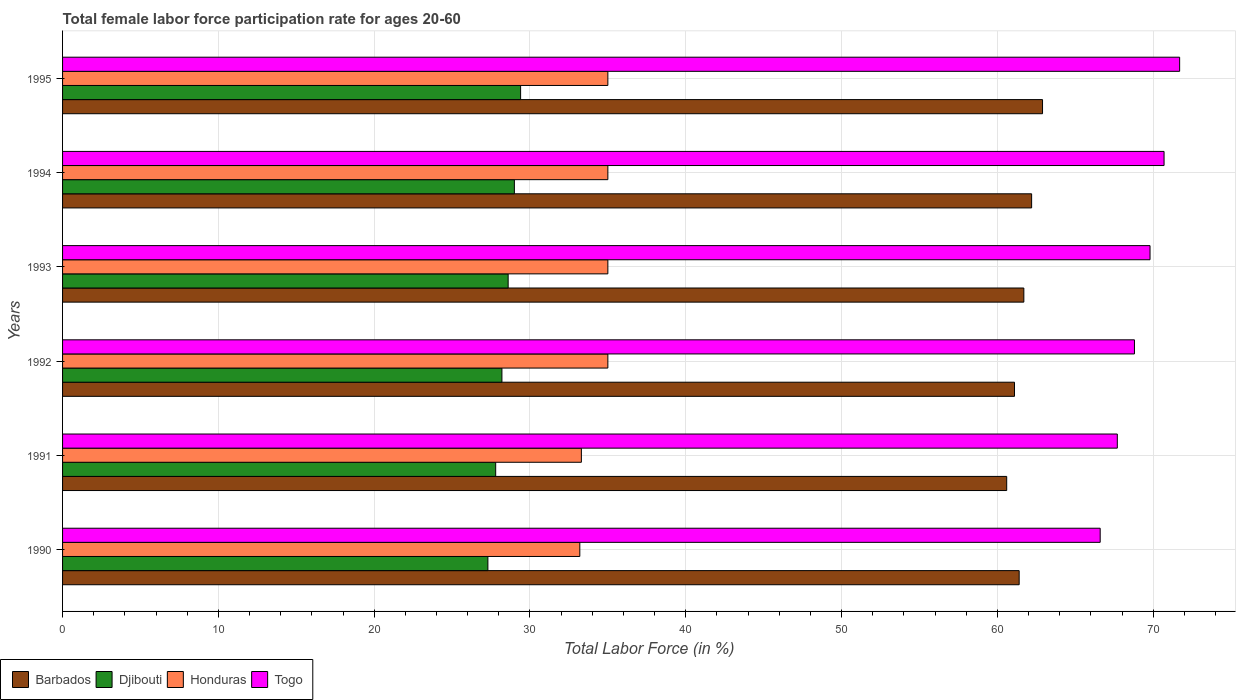How many groups of bars are there?
Your response must be concise. 6. Are the number of bars per tick equal to the number of legend labels?
Provide a succinct answer. Yes. Are the number of bars on each tick of the Y-axis equal?
Ensure brevity in your answer.  Yes. How many bars are there on the 3rd tick from the top?
Keep it short and to the point. 4. How many bars are there on the 4th tick from the bottom?
Your answer should be very brief. 4. What is the female labor force participation rate in Honduras in 1990?
Provide a short and direct response. 33.2. Across all years, what is the maximum female labor force participation rate in Barbados?
Provide a short and direct response. 62.9. Across all years, what is the minimum female labor force participation rate in Togo?
Your answer should be very brief. 66.6. In which year was the female labor force participation rate in Togo maximum?
Ensure brevity in your answer.  1995. What is the total female labor force participation rate in Barbados in the graph?
Offer a very short reply. 369.9. What is the difference between the female labor force participation rate in Honduras in 1990 and that in 1991?
Offer a very short reply. -0.1. What is the difference between the female labor force participation rate in Barbados in 1993 and the female labor force participation rate in Togo in 1995?
Your answer should be very brief. -10. What is the average female labor force participation rate in Honduras per year?
Your response must be concise. 34.42. In the year 1994, what is the difference between the female labor force participation rate in Honduras and female labor force participation rate in Djibouti?
Provide a short and direct response. 6. In how many years, is the female labor force participation rate in Barbados greater than 58 %?
Your answer should be compact. 6. What is the ratio of the female labor force participation rate in Djibouti in 1992 to that in 1995?
Give a very brief answer. 0.96. Is the female labor force participation rate in Djibouti in 1990 less than that in 1995?
Your response must be concise. Yes. What is the difference between the highest and the second highest female labor force participation rate in Barbados?
Your answer should be very brief. 0.7. What is the difference between the highest and the lowest female labor force participation rate in Honduras?
Offer a very short reply. 1.8. In how many years, is the female labor force participation rate in Togo greater than the average female labor force participation rate in Togo taken over all years?
Offer a terse response. 3. What does the 1st bar from the top in 1995 represents?
Your answer should be compact. Togo. What does the 2nd bar from the bottom in 1992 represents?
Offer a very short reply. Djibouti. Are the values on the major ticks of X-axis written in scientific E-notation?
Your response must be concise. No. Does the graph contain grids?
Your answer should be very brief. Yes. How many legend labels are there?
Your answer should be very brief. 4. What is the title of the graph?
Your answer should be very brief. Total female labor force participation rate for ages 20-60. Does "Zimbabwe" appear as one of the legend labels in the graph?
Offer a terse response. No. What is the label or title of the X-axis?
Give a very brief answer. Total Labor Force (in %). What is the label or title of the Y-axis?
Ensure brevity in your answer.  Years. What is the Total Labor Force (in %) of Barbados in 1990?
Offer a terse response. 61.4. What is the Total Labor Force (in %) of Djibouti in 1990?
Keep it short and to the point. 27.3. What is the Total Labor Force (in %) in Honduras in 1990?
Your response must be concise. 33.2. What is the Total Labor Force (in %) of Togo in 1990?
Your answer should be very brief. 66.6. What is the Total Labor Force (in %) of Barbados in 1991?
Keep it short and to the point. 60.6. What is the Total Labor Force (in %) of Djibouti in 1991?
Provide a short and direct response. 27.8. What is the Total Labor Force (in %) in Honduras in 1991?
Keep it short and to the point. 33.3. What is the Total Labor Force (in %) in Togo in 1991?
Keep it short and to the point. 67.7. What is the Total Labor Force (in %) of Barbados in 1992?
Your answer should be compact. 61.1. What is the Total Labor Force (in %) of Djibouti in 1992?
Offer a very short reply. 28.2. What is the Total Labor Force (in %) of Honduras in 1992?
Give a very brief answer. 35. What is the Total Labor Force (in %) of Togo in 1992?
Give a very brief answer. 68.8. What is the Total Labor Force (in %) in Barbados in 1993?
Provide a short and direct response. 61.7. What is the Total Labor Force (in %) in Djibouti in 1993?
Give a very brief answer. 28.6. What is the Total Labor Force (in %) of Togo in 1993?
Ensure brevity in your answer.  69.8. What is the Total Labor Force (in %) of Barbados in 1994?
Offer a very short reply. 62.2. What is the Total Labor Force (in %) of Togo in 1994?
Your response must be concise. 70.7. What is the Total Labor Force (in %) in Barbados in 1995?
Provide a short and direct response. 62.9. What is the Total Labor Force (in %) in Djibouti in 1995?
Provide a short and direct response. 29.4. What is the Total Labor Force (in %) of Togo in 1995?
Provide a short and direct response. 71.7. Across all years, what is the maximum Total Labor Force (in %) in Barbados?
Make the answer very short. 62.9. Across all years, what is the maximum Total Labor Force (in %) of Djibouti?
Your response must be concise. 29.4. Across all years, what is the maximum Total Labor Force (in %) of Honduras?
Your answer should be compact. 35. Across all years, what is the maximum Total Labor Force (in %) in Togo?
Provide a short and direct response. 71.7. Across all years, what is the minimum Total Labor Force (in %) of Barbados?
Offer a very short reply. 60.6. Across all years, what is the minimum Total Labor Force (in %) in Djibouti?
Make the answer very short. 27.3. Across all years, what is the minimum Total Labor Force (in %) of Honduras?
Keep it short and to the point. 33.2. Across all years, what is the minimum Total Labor Force (in %) in Togo?
Offer a very short reply. 66.6. What is the total Total Labor Force (in %) in Barbados in the graph?
Offer a terse response. 369.9. What is the total Total Labor Force (in %) in Djibouti in the graph?
Your answer should be compact. 170.3. What is the total Total Labor Force (in %) of Honduras in the graph?
Make the answer very short. 206.5. What is the total Total Labor Force (in %) of Togo in the graph?
Your response must be concise. 415.3. What is the difference between the Total Labor Force (in %) in Honduras in 1990 and that in 1992?
Provide a succinct answer. -1.8. What is the difference between the Total Labor Force (in %) in Honduras in 1990 and that in 1993?
Your answer should be compact. -1.8. What is the difference between the Total Labor Force (in %) of Togo in 1990 and that in 1993?
Give a very brief answer. -3.2. What is the difference between the Total Labor Force (in %) in Barbados in 1990 and that in 1994?
Offer a terse response. -0.8. What is the difference between the Total Labor Force (in %) of Djibouti in 1990 and that in 1994?
Make the answer very short. -1.7. What is the difference between the Total Labor Force (in %) of Togo in 1990 and that in 1994?
Ensure brevity in your answer.  -4.1. What is the difference between the Total Labor Force (in %) of Barbados in 1990 and that in 1995?
Offer a terse response. -1.5. What is the difference between the Total Labor Force (in %) of Djibouti in 1990 and that in 1995?
Provide a succinct answer. -2.1. What is the difference between the Total Labor Force (in %) in Togo in 1990 and that in 1995?
Ensure brevity in your answer.  -5.1. What is the difference between the Total Labor Force (in %) of Barbados in 1991 and that in 1992?
Your answer should be compact. -0.5. What is the difference between the Total Labor Force (in %) in Barbados in 1991 and that in 1993?
Your response must be concise. -1.1. What is the difference between the Total Labor Force (in %) of Djibouti in 1991 and that in 1993?
Give a very brief answer. -0.8. What is the difference between the Total Labor Force (in %) of Togo in 1991 and that in 1993?
Your response must be concise. -2.1. What is the difference between the Total Labor Force (in %) in Barbados in 1991 and that in 1994?
Make the answer very short. -1.6. What is the difference between the Total Labor Force (in %) in Honduras in 1991 and that in 1994?
Your answer should be compact. -1.7. What is the difference between the Total Labor Force (in %) in Togo in 1991 and that in 1994?
Provide a succinct answer. -3. What is the difference between the Total Labor Force (in %) of Barbados in 1991 and that in 1995?
Give a very brief answer. -2.3. What is the difference between the Total Labor Force (in %) in Djibouti in 1991 and that in 1995?
Provide a short and direct response. -1.6. What is the difference between the Total Labor Force (in %) in Togo in 1991 and that in 1995?
Provide a succinct answer. -4. What is the difference between the Total Labor Force (in %) in Djibouti in 1992 and that in 1993?
Offer a terse response. -0.4. What is the difference between the Total Labor Force (in %) of Djibouti in 1992 and that in 1994?
Ensure brevity in your answer.  -0.8. What is the difference between the Total Labor Force (in %) in Honduras in 1992 and that in 1994?
Offer a very short reply. 0. What is the difference between the Total Labor Force (in %) of Djibouti in 1992 and that in 1995?
Offer a terse response. -1.2. What is the difference between the Total Labor Force (in %) of Djibouti in 1993 and that in 1994?
Provide a succinct answer. -0.4. What is the difference between the Total Labor Force (in %) in Togo in 1993 and that in 1994?
Offer a terse response. -0.9. What is the difference between the Total Labor Force (in %) in Togo in 1993 and that in 1995?
Make the answer very short. -1.9. What is the difference between the Total Labor Force (in %) in Barbados in 1994 and that in 1995?
Your answer should be very brief. -0.7. What is the difference between the Total Labor Force (in %) of Djibouti in 1994 and that in 1995?
Your answer should be very brief. -0.4. What is the difference between the Total Labor Force (in %) of Honduras in 1994 and that in 1995?
Ensure brevity in your answer.  0. What is the difference between the Total Labor Force (in %) in Barbados in 1990 and the Total Labor Force (in %) in Djibouti in 1991?
Provide a succinct answer. 33.6. What is the difference between the Total Labor Force (in %) of Barbados in 1990 and the Total Labor Force (in %) of Honduras in 1991?
Offer a terse response. 28.1. What is the difference between the Total Labor Force (in %) in Barbados in 1990 and the Total Labor Force (in %) in Togo in 1991?
Your response must be concise. -6.3. What is the difference between the Total Labor Force (in %) of Djibouti in 1990 and the Total Labor Force (in %) of Honduras in 1991?
Provide a short and direct response. -6. What is the difference between the Total Labor Force (in %) in Djibouti in 1990 and the Total Labor Force (in %) in Togo in 1991?
Your answer should be compact. -40.4. What is the difference between the Total Labor Force (in %) of Honduras in 1990 and the Total Labor Force (in %) of Togo in 1991?
Offer a terse response. -34.5. What is the difference between the Total Labor Force (in %) in Barbados in 1990 and the Total Labor Force (in %) in Djibouti in 1992?
Provide a succinct answer. 33.2. What is the difference between the Total Labor Force (in %) in Barbados in 1990 and the Total Labor Force (in %) in Honduras in 1992?
Your response must be concise. 26.4. What is the difference between the Total Labor Force (in %) of Djibouti in 1990 and the Total Labor Force (in %) of Honduras in 1992?
Your answer should be compact. -7.7. What is the difference between the Total Labor Force (in %) in Djibouti in 1990 and the Total Labor Force (in %) in Togo in 1992?
Offer a very short reply. -41.5. What is the difference between the Total Labor Force (in %) in Honduras in 1990 and the Total Labor Force (in %) in Togo in 1992?
Your answer should be compact. -35.6. What is the difference between the Total Labor Force (in %) in Barbados in 1990 and the Total Labor Force (in %) in Djibouti in 1993?
Provide a short and direct response. 32.8. What is the difference between the Total Labor Force (in %) of Barbados in 1990 and the Total Labor Force (in %) of Honduras in 1993?
Make the answer very short. 26.4. What is the difference between the Total Labor Force (in %) of Djibouti in 1990 and the Total Labor Force (in %) of Honduras in 1993?
Ensure brevity in your answer.  -7.7. What is the difference between the Total Labor Force (in %) in Djibouti in 1990 and the Total Labor Force (in %) in Togo in 1993?
Offer a very short reply. -42.5. What is the difference between the Total Labor Force (in %) in Honduras in 1990 and the Total Labor Force (in %) in Togo in 1993?
Your answer should be compact. -36.6. What is the difference between the Total Labor Force (in %) in Barbados in 1990 and the Total Labor Force (in %) in Djibouti in 1994?
Offer a terse response. 32.4. What is the difference between the Total Labor Force (in %) of Barbados in 1990 and the Total Labor Force (in %) of Honduras in 1994?
Offer a terse response. 26.4. What is the difference between the Total Labor Force (in %) of Barbados in 1990 and the Total Labor Force (in %) of Togo in 1994?
Provide a succinct answer. -9.3. What is the difference between the Total Labor Force (in %) of Djibouti in 1990 and the Total Labor Force (in %) of Honduras in 1994?
Provide a succinct answer. -7.7. What is the difference between the Total Labor Force (in %) in Djibouti in 1990 and the Total Labor Force (in %) in Togo in 1994?
Make the answer very short. -43.4. What is the difference between the Total Labor Force (in %) of Honduras in 1990 and the Total Labor Force (in %) of Togo in 1994?
Your response must be concise. -37.5. What is the difference between the Total Labor Force (in %) of Barbados in 1990 and the Total Labor Force (in %) of Honduras in 1995?
Your answer should be compact. 26.4. What is the difference between the Total Labor Force (in %) in Djibouti in 1990 and the Total Labor Force (in %) in Togo in 1995?
Your answer should be compact. -44.4. What is the difference between the Total Labor Force (in %) of Honduras in 1990 and the Total Labor Force (in %) of Togo in 1995?
Your response must be concise. -38.5. What is the difference between the Total Labor Force (in %) in Barbados in 1991 and the Total Labor Force (in %) in Djibouti in 1992?
Make the answer very short. 32.4. What is the difference between the Total Labor Force (in %) of Barbados in 1991 and the Total Labor Force (in %) of Honduras in 1992?
Your response must be concise. 25.6. What is the difference between the Total Labor Force (in %) in Barbados in 1991 and the Total Labor Force (in %) in Togo in 1992?
Keep it short and to the point. -8.2. What is the difference between the Total Labor Force (in %) in Djibouti in 1991 and the Total Labor Force (in %) in Honduras in 1992?
Offer a very short reply. -7.2. What is the difference between the Total Labor Force (in %) in Djibouti in 1991 and the Total Labor Force (in %) in Togo in 1992?
Make the answer very short. -41. What is the difference between the Total Labor Force (in %) of Honduras in 1991 and the Total Labor Force (in %) of Togo in 1992?
Give a very brief answer. -35.5. What is the difference between the Total Labor Force (in %) in Barbados in 1991 and the Total Labor Force (in %) in Honduras in 1993?
Your answer should be compact. 25.6. What is the difference between the Total Labor Force (in %) of Djibouti in 1991 and the Total Labor Force (in %) of Togo in 1993?
Give a very brief answer. -42. What is the difference between the Total Labor Force (in %) of Honduras in 1991 and the Total Labor Force (in %) of Togo in 1993?
Offer a terse response. -36.5. What is the difference between the Total Labor Force (in %) in Barbados in 1991 and the Total Labor Force (in %) in Djibouti in 1994?
Offer a very short reply. 31.6. What is the difference between the Total Labor Force (in %) of Barbados in 1991 and the Total Labor Force (in %) of Honduras in 1994?
Offer a very short reply. 25.6. What is the difference between the Total Labor Force (in %) in Barbados in 1991 and the Total Labor Force (in %) in Togo in 1994?
Your response must be concise. -10.1. What is the difference between the Total Labor Force (in %) of Djibouti in 1991 and the Total Labor Force (in %) of Honduras in 1994?
Your answer should be very brief. -7.2. What is the difference between the Total Labor Force (in %) in Djibouti in 1991 and the Total Labor Force (in %) in Togo in 1994?
Your response must be concise. -42.9. What is the difference between the Total Labor Force (in %) in Honduras in 1991 and the Total Labor Force (in %) in Togo in 1994?
Ensure brevity in your answer.  -37.4. What is the difference between the Total Labor Force (in %) in Barbados in 1991 and the Total Labor Force (in %) in Djibouti in 1995?
Keep it short and to the point. 31.2. What is the difference between the Total Labor Force (in %) of Barbados in 1991 and the Total Labor Force (in %) of Honduras in 1995?
Offer a very short reply. 25.6. What is the difference between the Total Labor Force (in %) of Djibouti in 1991 and the Total Labor Force (in %) of Togo in 1995?
Your answer should be very brief. -43.9. What is the difference between the Total Labor Force (in %) in Honduras in 1991 and the Total Labor Force (in %) in Togo in 1995?
Give a very brief answer. -38.4. What is the difference between the Total Labor Force (in %) in Barbados in 1992 and the Total Labor Force (in %) in Djibouti in 1993?
Offer a terse response. 32.5. What is the difference between the Total Labor Force (in %) of Barbados in 1992 and the Total Labor Force (in %) of Honduras in 1993?
Your response must be concise. 26.1. What is the difference between the Total Labor Force (in %) of Djibouti in 1992 and the Total Labor Force (in %) of Togo in 1993?
Provide a succinct answer. -41.6. What is the difference between the Total Labor Force (in %) in Honduras in 1992 and the Total Labor Force (in %) in Togo in 1993?
Your response must be concise. -34.8. What is the difference between the Total Labor Force (in %) of Barbados in 1992 and the Total Labor Force (in %) of Djibouti in 1994?
Offer a terse response. 32.1. What is the difference between the Total Labor Force (in %) in Barbados in 1992 and the Total Labor Force (in %) in Honduras in 1994?
Offer a very short reply. 26.1. What is the difference between the Total Labor Force (in %) of Barbados in 1992 and the Total Labor Force (in %) of Togo in 1994?
Your answer should be compact. -9.6. What is the difference between the Total Labor Force (in %) of Djibouti in 1992 and the Total Labor Force (in %) of Togo in 1994?
Provide a short and direct response. -42.5. What is the difference between the Total Labor Force (in %) of Honduras in 1992 and the Total Labor Force (in %) of Togo in 1994?
Your answer should be very brief. -35.7. What is the difference between the Total Labor Force (in %) in Barbados in 1992 and the Total Labor Force (in %) in Djibouti in 1995?
Your answer should be very brief. 31.7. What is the difference between the Total Labor Force (in %) of Barbados in 1992 and the Total Labor Force (in %) of Honduras in 1995?
Ensure brevity in your answer.  26.1. What is the difference between the Total Labor Force (in %) in Djibouti in 1992 and the Total Labor Force (in %) in Honduras in 1995?
Provide a short and direct response. -6.8. What is the difference between the Total Labor Force (in %) of Djibouti in 1992 and the Total Labor Force (in %) of Togo in 1995?
Make the answer very short. -43.5. What is the difference between the Total Labor Force (in %) of Honduras in 1992 and the Total Labor Force (in %) of Togo in 1995?
Provide a succinct answer. -36.7. What is the difference between the Total Labor Force (in %) of Barbados in 1993 and the Total Labor Force (in %) of Djibouti in 1994?
Provide a succinct answer. 32.7. What is the difference between the Total Labor Force (in %) of Barbados in 1993 and the Total Labor Force (in %) of Honduras in 1994?
Offer a very short reply. 26.7. What is the difference between the Total Labor Force (in %) in Djibouti in 1993 and the Total Labor Force (in %) in Togo in 1994?
Offer a very short reply. -42.1. What is the difference between the Total Labor Force (in %) in Honduras in 1993 and the Total Labor Force (in %) in Togo in 1994?
Your answer should be very brief. -35.7. What is the difference between the Total Labor Force (in %) of Barbados in 1993 and the Total Labor Force (in %) of Djibouti in 1995?
Ensure brevity in your answer.  32.3. What is the difference between the Total Labor Force (in %) of Barbados in 1993 and the Total Labor Force (in %) of Honduras in 1995?
Offer a very short reply. 26.7. What is the difference between the Total Labor Force (in %) in Barbados in 1993 and the Total Labor Force (in %) in Togo in 1995?
Provide a short and direct response. -10. What is the difference between the Total Labor Force (in %) of Djibouti in 1993 and the Total Labor Force (in %) of Togo in 1995?
Give a very brief answer. -43.1. What is the difference between the Total Labor Force (in %) in Honduras in 1993 and the Total Labor Force (in %) in Togo in 1995?
Offer a very short reply. -36.7. What is the difference between the Total Labor Force (in %) of Barbados in 1994 and the Total Labor Force (in %) of Djibouti in 1995?
Provide a short and direct response. 32.8. What is the difference between the Total Labor Force (in %) in Barbados in 1994 and the Total Labor Force (in %) in Honduras in 1995?
Offer a terse response. 27.2. What is the difference between the Total Labor Force (in %) in Barbados in 1994 and the Total Labor Force (in %) in Togo in 1995?
Keep it short and to the point. -9.5. What is the difference between the Total Labor Force (in %) in Djibouti in 1994 and the Total Labor Force (in %) in Togo in 1995?
Keep it short and to the point. -42.7. What is the difference between the Total Labor Force (in %) in Honduras in 1994 and the Total Labor Force (in %) in Togo in 1995?
Ensure brevity in your answer.  -36.7. What is the average Total Labor Force (in %) in Barbados per year?
Your response must be concise. 61.65. What is the average Total Labor Force (in %) in Djibouti per year?
Give a very brief answer. 28.38. What is the average Total Labor Force (in %) in Honduras per year?
Offer a terse response. 34.42. What is the average Total Labor Force (in %) in Togo per year?
Offer a terse response. 69.22. In the year 1990, what is the difference between the Total Labor Force (in %) of Barbados and Total Labor Force (in %) of Djibouti?
Provide a short and direct response. 34.1. In the year 1990, what is the difference between the Total Labor Force (in %) of Barbados and Total Labor Force (in %) of Honduras?
Your answer should be very brief. 28.2. In the year 1990, what is the difference between the Total Labor Force (in %) in Djibouti and Total Labor Force (in %) in Honduras?
Give a very brief answer. -5.9. In the year 1990, what is the difference between the Total Labor Force (in %) of Djibouti and Total Labor Force (in %) of Togo?
Your answer should be compact. -39.3. In the year 1990, what is the difference between the Total Labor Force (in %) of Honduras and Total Labor Force (in %) of Togo?
Your response must be concise. -33.4. In the year 1991, what is the difference between the Total Labor Force (in %) in Barbados and Total Labor Force (in %) in Djibouti?
Offer a very short reply. 32.8. In the year 1991, what is the difference between the Total Labor Force (in %) in Barbados and Total Labor Force (in %) in Honduras?
Offer a terse response. 27.3. In the year 1991, what is the difference between the Total Labor Force (in %) in Djibouti and Total Labor Force (in %) in Honduras?
Provide a short and direct response. -5.5. In the year 1991, what is the difference between the Total Labor Force (in %) in Djibouti and Total Labor Force (in %) in Togo?
Provide a succinct answer. -39.9. In the year 1991, what is the difference between the Total Labor Force (in %) in Honduras and Total Labor Force (in %) in Togo?
Provide a succinct answer. -34.4. In the year 1992, what is the difference between the Total Labor Force (in %) of Barbados and Total Labor Force (in %) of Djibouti?
Your answer should be compact. 32.9. In the year 1992, what is the difference between the Total Labor Force (in %) in Barbados and Total Labor Force (in %) in Honduras?
Keep it short and to the point. 26.1. In the year 1992, what is the difference between the Total Labor Force (in %) in Barbados and Total Labor Force (in %) in Togo?
Provide a succinct answer. -7.7. In the year 1992, what is the difference between the Total Labor Force (in %) in Djibouti and Total Labor Force (in %) in Honduras?
Give a very brief answer. -6.8. In the year 1992, what is the difference between the Total Labor Force (in %) in Djibouti and Total Labor Force (in %) in Togo?
Your answer should be very brief. -40.6. In the year 1992, what is the difference between the Total Labor Force (in %) of Honduras and Total Labor Force (in %) of Togo?
Provide a short and direct response. -33.8. In the year 1993, what is the difference between the Total Labor Force (in %) in Barbados and Total Labor Force (in %) in Djibouti?
Provide a short and direct response. 33.1. In the year 1993, what is the difference between the Total Labor Force (in %) in Barbados and Total Labor Force (in %) in Honduras?
Offer a very short reply. 26.7. In the year 1993, what is the difference between the Total Labor Force (in %) of Djibouti and Total Labor Force (in %) of Honduras?
Provide a short and direct response. -6.4. In the year 1993, what is the difference between the Total Labor Force (in %) of Djibouti and Total Labor Force (in %) of Togo?
Make the answer very short. -41.2. In the year 1993, what is the difference between the Total Labor Force (in %) in Honduras and Total Labor Force (in %) in Togo?
Your answer should be very brief. -34.8. In the year 1994, what is the difference between the Total Labor Force (in %) of Barbados and Total Labor Force (in %) of Djibouti?
Make the answer very short. 33.2. In the year 1994, what is the difference between the Total Labor Force (in %) of Barbados and Total Labor Force (in %) of Honduras?
Offer a terse response. 27.2. In the year 1994, what is the difference between the Total Labor Force (in %) in Barbados and Total Labor Force (in %) in Togo?
Your response must be concise. -8.5. In the year 1994, what is the difference between the Total Labor Force (in %) in Djibouti and Total Labor Force (in %) in Togo?
Your answer should be compact. -41.7. In the year 1994, what is the difference between the Total Labor Force (in %) of Honduras and Total Labor Force (in %) of Togo?
Offer a terse response. -35.7. In the year 1995, what is the difference between the Total Labor Force (in %) of Barbados and Total Labor Force (in %) of Djibouti?
Keep it short and to the point. 33.5. In the year 1995, what is the difference between the Total Labor Force (in %) of Barbados and Total Labor Force (in %) of Honduras?
Provide a short and direct response. 27.9. In the year 1995, what is the difference between the Total Labor Force (in %) in Djibouti and Total Labor Force (in %) in Togo?
Keep it short and to the point. -42.3. In the year 1995, what is the difference between the Total Labor Force (in %) of Honduras and Total Labor Force (in %) of Togo?
Provide a succinct answer. -36.7. What is the ratio of the Total Labor Force (in %) in Barbados in 1990 to that in 1991?
Provide a short and direct response. 1.01. What is the ratio of the Total Labor Force (in %) in Honduras in 1990 to that in 1991?
Provide a succinct answer. 1. What is the ratio of the Total Labor Force (in %) of Togo in 1990 to that in 1991?
Keep it short and to the point. 0.98. What is the ratio of the Total Labor Force (in %) in Barbados in 1990 to that in 1992?
Your response must be concise. 1. What is the ratio of the Total Labor Force (in %) in Djibouti in 1990 to that in 1992?
Offer a terse response. 0.97. What is the ratio of the Total Labor Force (in %) of Honduras in 1990 to that in 1992?
Give a very brief answer. 0.95. What is the ratio of the Total Labor Force (in %) of Togo in 1990 to that in 1992?
Offer a very short reply. 0.97. What is the ratio of the Total Labor Force (in %) in Barbados in 1990 to that in 1993?
Offer a terse response. 1. What is the ratio of the Total Labor Force (in %) in Djibouti in 1990 to that in 1993?
Your answer should be very brief. 0.95. What is the ratio of the Total Labor Force (in %) in Honduras in 1990 to that in 1993?
Your answer should be compact. 0.95. What is the ratio of the Total Labor Force (in %) of Togo in 1990 to that in 1993?
Give a very brief answer. 0.95. What is the ratio of the Total Labor Force (in %) of Barbados in 1990 to that in 1994?
Keep it short and to the point. 0.99. What is the ratio of the Total Labor Force (in %) in Djibouti in 1990 to that in 1994?
Offer a very short reply. 0.94. What is the ratio of the Total Labor Force (in %) of Honduras in 1990 to that in 1994?
Provide a succinct answer. 0.95. What is the ratio of the Total Labor Force (in %) of Togo in 1990 to that in 1994?
Give a very brief answer. 0.94. What is the ratio of the Total Labor Force (in %) in Barbados in 1990 to that in 1995?
Keep it short and to the point. 0.98. What is the ratio of the Total Labor Force (in %) in Honduras in 1990 to that in 1995?
Provide a short and direct response. 0.95. What is the ratio of the Total Labor Force (in %) in Togo in 1990 to that in 1995?
Provide a succinct answer. 0.93. What is the ratio of the Total Labor Force (in %) in Djibouti in 1991 to that in 1992?
Give a very brief answer. 0.99. What is the ratio of the Total Labor Force (in %) in Honduras in 1991 to that in 1992?
Ensure brevity in your answer.  0.95. What is the ratio of the Total Labor Force (in %) of Togo in 1991 to that in 1992?
Provide a succinct answer. 0.98. What is the ratio of the Total Labor Force (in %) in Barbados in 1991 to that in 1993?
Your answer should be compact. 0.98. What is the ratio of the Total Labor Force (in %) of Djibouti in 1991 to that in 1993?
Provide a succinct answer. 0.97. What is the ratio of the Total Labor Force (in %) in Honduras in 1991 to that in 1993?
Offer a very short reply. 0.95. What is the ratio of the Total Labor Force (in %) of Togo in 1991 to that in 1993?
Offer a terse response. 0.97. What is the ratio of the Total Labor Force (in %) in Barbados in 1991 to that in 1994?
Ensure brevity in your answer.  0.97. What is the ratio of the Total Labor Force (in %) of Djibouti in 1991 to that in 1994?
Ensure brevity in your answer.  0.96. What is the ratio of the Total Labor Force (in %) in Honduras in 1991 to that in 1994?
Your response must be concise. 0.95. What is the ratio of the Total Labor Force (in %) of Togo in 1991 to that in 1994?
Provide a short and direct response. 0.96. What is the ratio of the Total Labor Force (in %) in Barbados in 1991 to that in 1995?
Your answer should be very brief. 0.96. What is the ratio of the Total Labor Force (in %) in Djibouti in 1991 to that in 1995?
Offer a terse response. 0.95. What is the ratio of the Total Labor Force (in %) in Honduras in 1991 to that in 1995?
Offer a terse response. 0.95. What is the ratio of the Total Labor Force (in %) in Togo in 1991 to that in 1995?
Give a very brief answer. 0.94. What is the ratio of the Total Labor Force (in %) of Barbados in 1992 to that in 1993?
Provide a succinct answer. 0.99. What is the ratio of the Total Labor Force (in %) in Honduras in 1992 to that in 1993?
Offer a very short reply. 1. What is the ratio of the Total Labor Force (in %) of Togo in 1992 to that in 1993?
Provide a short and direct response. 0.99. What is the ratio of the Total Labor Force (in %) in Barbados in 1992 to that in 1994?
Your response must be concise. 0.98. What is the ratio of the Total Labor Force (in %) in Djibouti in 1992 to that in 1994?
Offer a very short reply. 0.97. What is the ratio of the Total Labor Force (in %) in Honduras in 1992 to that in 1994?
Your answer should be compact. 1. What is the ratio of the Total Labor Force (in %) in Togo in 1992 to that in 1994?
Offer a terse response. 0.97. What is the ratio of the Total Labor Force (in %) of Barbados in 1992 to that in 1995?
Your answer should be very brief. 0.97. What is the ratio of the Total Labor Force (in %) in Djibouti in 1992 to that in 1995?
Offer a terse response. 0.96. What is the ratio of the Total Labor Force (in %) in Togo in 1992 to that in 1995?
Provide a short and direct response. 0.96. What is the ratio of the Total Labor Force (in %) of Barbados in 1993 to that in 1994?
Offer a very short reply. 0.99. What is the ratio of the Total Labor Force (in %) in Djibouti in 1993 to that in 1994?
Provide a succinct answer. 0.99. What is the ratio of the Total Labor Force (in %) of Honduras in 1993 to that in 1994?
Your response must be concise. 1. What is the ratio of the Total Labor Force (in %) of Togo in 1993 to that in 1994?
Provide a short and direct response. 0.99. What is the ratio of the Total Labor Force (in %) in Barbados in 1993 to that in 1995?
Your answer should be very brief. 0.98. What is the ratio of the Total Labor Force (in %) of Djibouti in 1993 to that in 1995?
Your response must be concise. 0.97. What is the ratio of the Total Labor Force (in %) of Honduras in 1993 to that in 1995?
Give a very brief answer. 1. What is the ratio of the Total Labor Force (in %) in Togo in 1993 to that in 1995?
Your response must be concise. 0.97. What is the ratio of the Total Labor Force (in %) in Barbados in 1994 to that in 1995?
Provide a short and direct response. 0.99. What is the ratio of the Total Labor Force (in %) in Djibouti in 1994 to that in 1995?
Your response must be concise. 0.99. What is the ratio of the Total Labor Force (in %) of Honduras in 1994 to that in 1995?
Give a very brief answer. 1. What is the ratio of the Total Labor Force (in %) of Togo in 1994 to that in 1995?
Keep it short and to the point. 0.99. What is the difference between the highest and the second highest Total Labor Force (in %) of Barbados?
Make the answer very short. 0.7. What is the difference between the highest and the second highest Total Labor Force (in %) of Djibouti?
Your answer should be compact. 0.4. What is the difference between the highest and the lowest Total Labor Force (in %) of Barbados?
Offer a very short reply. 2.3. What is the difference between the highest and the lowest Total Labor Force (in %) of Honduras?
Make the answer very short. 1.8. What is the difference between the highest and the lowest Total Labor Force (in %) in Togo?
Provide a short and direct response. 5.1. 